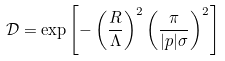<formula> <loc_0><loc_0><loc_500><loc_500>\mathcal { D } = \exp \left [ - \left ( \frac { R } { \Lambda } \right ) ^ { 2 } \left ( \frac { \pi } { | p | \sigma } \right ) ^ { 2 } \right ]</formula> 